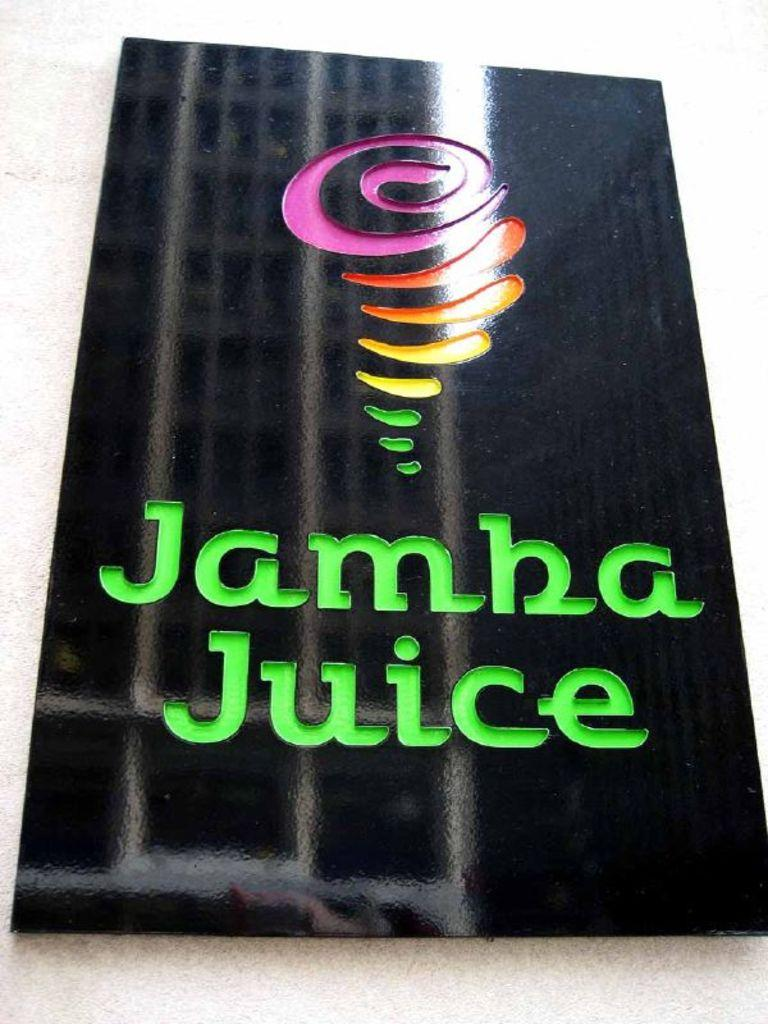<image>
Summarize the visual content of the image. A black sign with the words Jamba Juice on it. 